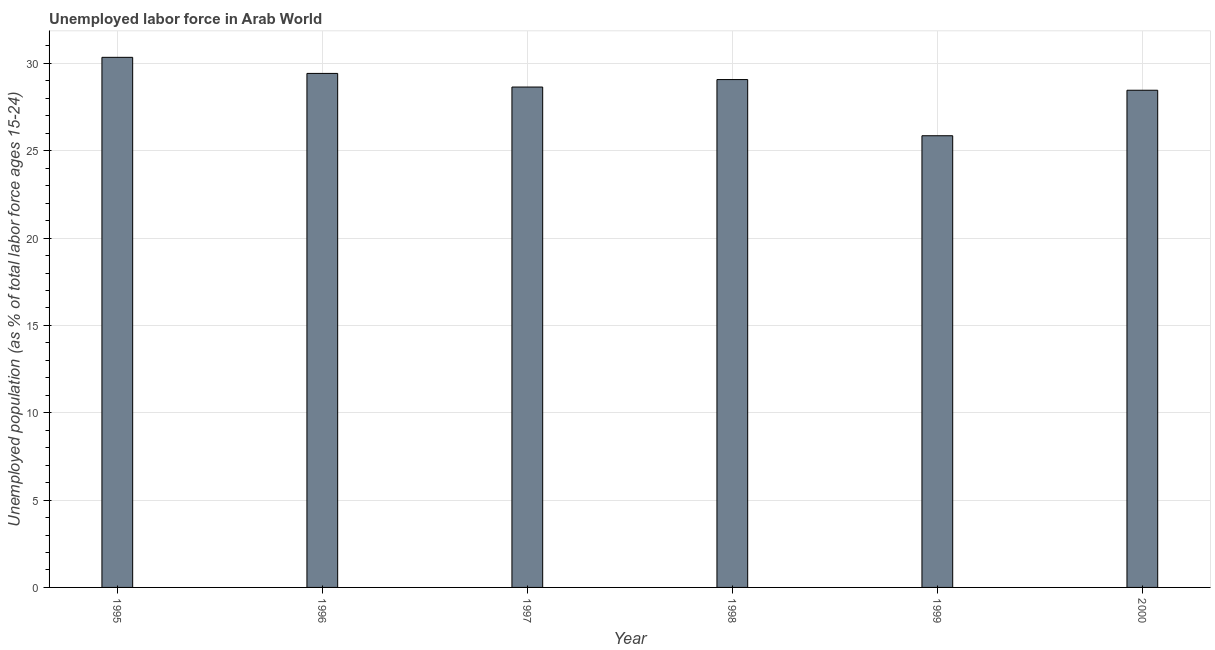Does the graph contain grids?
Provide a succinct answer. Yes. What is the title of the graph?
Your response must be concise. Unemployed labor force in Arab World. What is the label or title of the Y-axis?
Give a very brief answer. Unemployed population (as % of total labor force ages 15-24). What is the total unemployed youth population in 1995?
Ensure brevity in your answer.  30.35. Across all years, what is the maximum total unemployed youth population?
Ensure brevity in your answer.  30.35. Across all years, what is the minimum total unemployed youth population?
Make the answer very short. 25.86. In which year was the total unemployed youth population minimum?
Make the answer very short. 1999. What is the sum of the total unemployed youth population?
Your answer should be compact. 171.81. What is the difference between the total unemployed youth population in 1995 and 1998?
Give a very brief answer. 1.27. What is the average total unemployed youth population per year?
Ensure brevity in your answer.  28.64. What is the median total unemployed youth population?
Provide a short and direct response. 28.86. Do a majority of the years between 1998 and 1997 (inclusive) have total unemployed youth population greater than 30 %?
Provide a succinct answer. No. What is the ratio of the total unemployed youth population in 1997 to that in 1999?
Provide a succinct answer. 1.11. What is the difference between the highest and the second highest total unemployed youth population?
Give a very brief answer. 0.92. Is the sum of the total unemployed youth population in 1996 and 1999 greater than the maximum total unemployed youth population across all years?
Ensure brevity in your answer.  Yes. What is the difference between the highest and the lowest total unemployed youth population?
Provide a succinct answer. 4.49. In how many years, is the total unemployed youth population greater than the average total unemployed youth population taken over all years?
Offer a very short reply. 4. How many bars are there?
Keep it short and to the point. 6. How many years are there in the graph?
Your response must be concise. 6. Are the values on the major ticks of Y-axis written in scientific E-notation?
Your response must be concise. No. What is the Unemployed population (as % of total labor force ages 15-24) of 1995?
Your response must be concise. 30.35. What is the Unemployed population (as % of total labor force ages 15-24) of 1996?
Your answer should be compact. 29.43. What is the Unemployed population (as % of total labor force ages 15-24) in 1997?
Offer a terse response. 28.65. What is the Unemployed population (as % of total labor force ages 15-24) in 1998?
Provide a succinct answer. 29.07. What is the Unemployed population (as % of total labor force ages 15-24) in 1999?
Provide a short and direct response. 25.86. What is the Unemployed population (as % of total labor force ages 15-24) in 2000?
Keep it short and to the point. 28.46. What is the difference between the Unemployed population (as % of total labor force ages 15-24) in 1995 and 1996?
Provide a short and direct response. 0.92. What is the difference between the Unemployed population (as % of total labor force ages 15-24) in 1995 and 1997?
Offer a terse response. 1.7. What is the difference between the Unemployed population (as % of total labor force ages 15-24) in 1995 and 1998?
Keep it short and to the point. 1.27. What is the difference between the Unemployed population (as % of total labor force ages 15-24) in 1995 and 1999?
Make the answer very short. 4.49. What is the difference between the Unemployed population (as % of total labor force ages 15-24) in 1995 and 2000?
Provide a short and direct response. 1.88. What is the difference between the Unemployed population (as % of total labor force ages 15-24) in 1996 and 1997?
Offer a terse response. 0.78. What is the difference between the Unemployed population (as % of total labor force ages 15-24) in 1996 and 1998?
Your response must be concise. 0.35. What is the difference between the Unemployed population (as % of total labor force ages 15-24) in 1996 and 1999?
Provide a short and direct response. 3.57. What is the difference between the Unemployed population (as % of total labor force ages 15-24) in 1996 and 2000?
Make the answer very short. 0.96. What is the difference between the Unemployed population (as % of total labor force ages 15-24) in 1997 and 1998?
Provide a short and direct response. -0.43. What is the difference between the Unemployed population (as % of total labor force ages 15-24) in 1997 and 1999?
Give a very brief answer. 2.79. What is the difference between the Unemployed population (as % of total labor force ages 15-24) in 1997 and 2000?
Provide a succinct answer. 0.18. What is the difference between the Unemployed population (as % of total labor force ages 15-24) in 1998 and 1999?
Keep it short and to the point. 3.22. What is the difference between the Unemployed population (as % of total labor force ages 15-24) in 1998 and 2000?
Your response must be concise. 0.61. What is the difference between the Unemployed population (as % of total labor force ages 15-24) in 1999 and 2000?
Provide a succinct answer. -2.6. What is the ratio of the Unemployed population (as % of total labor force ages 15-24) in 1995 to that in 1996?
Give a very brief answer. 1.03. What is the ratio of the Unemployed population (as % of total labor force ages 15-24) in 1995 to that in 1997?
Your answer should be very brief. 1.06. What is the ratio of the Unemployed population (as % of total labor force ages 15-24) in 1995 to that in 1998?
Keep it short and to the point. 1.04. What is the ratio of the Unemployed population (as % of total labor force ages 15-24) in 1995 to that in 1999?
Offer a very short reply. 1.17. What is the ratio of the Unemployed population (as % of total labor force ages 15-24) in 1995 to that in 2000?
Your answer should be compact. 1.07. What is the ratio of the Unemployed population (as % of total labor force ages 15-24) in 1996 to that in 1998?
Ensure brevity in your answer.  1.01. What is the ratio of the Unemployed population (as % of total labor force ages 15-24) in 1996 to that in 1999?
Provide a short and direct response. 1.14. What is the ratio of the Unemployed population (as % of total labor force ages 15-24) in 1996 to that in 2000?
Give a very brief answer. 1.03. What is the ratio of the Unemployed population (as % of total labor force ages 15-24) in 1997 to that in 1998?
Provide a short and direct response. 0.98. What is the ratio of the Unemployed population (as % of total labor force ages 15-24) in 1997 to that in 1999?
Your response must be concise. 1.11. What is the ratio of the Unemployed population (as % of total labor force ages 15-24) in 1997 to that in 2000?
Offer a terse response. 1.01. What is the ratio of the Unemployed population (as % of total labor force ages 15-24) in 1998 to that in 1999?
Your answer should be compact. 1.12. What is the ratio of the Unemployed population (as % of total labor force ages 15-24) in 1998 to that in 2000?
Offer a terse response. 1.02. What is the ratio of the Unemployed population (as % of total labor force ages 15-24) in 1999 to that in 2000?
Offer a terse response. 0.91. 